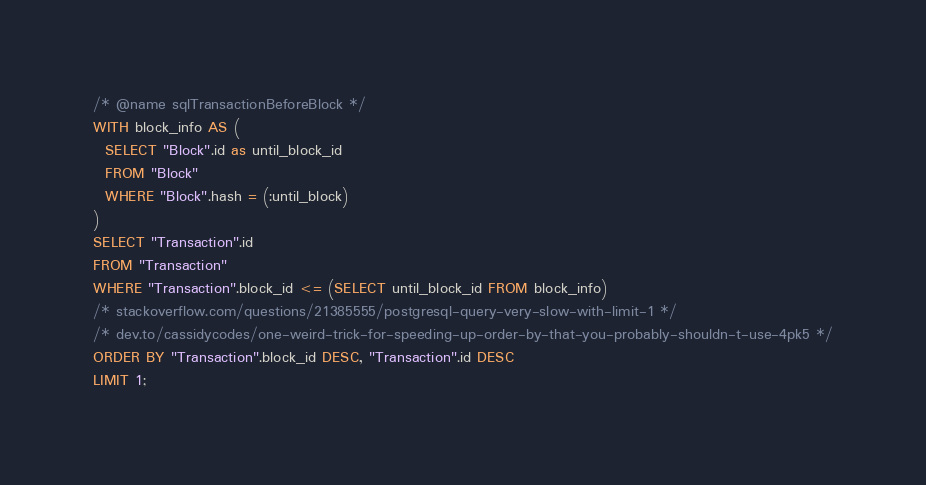<code> <loc_0><loc_0><loc_500><loc_500><_SQL_>/* @name sqlTransactionBeforeBlock */
WITH block_info AS (
  SELECT "Block".id as until_block_id
  FROM "Block"
  WHERE "Block".hash = (:until_block)
)
SELECT "Transaction".id
FROM "Transaction"
WHERE "Transaction".block_id <= (SELECT until_block_id FROM block_info)
/* stackoverflow.com/questions/21385555/postgresql-query-very-slow-with-limit-1 */
/* dev.to/cassidycodes/one-weird-trick-for-speeding-up-order-by-that-you-probably-shouldn-t-use-4pk5 */
ORDER BY "Transaction".block_id DESC, "Transaction".id DESC
LIMIT 1;
</code> 